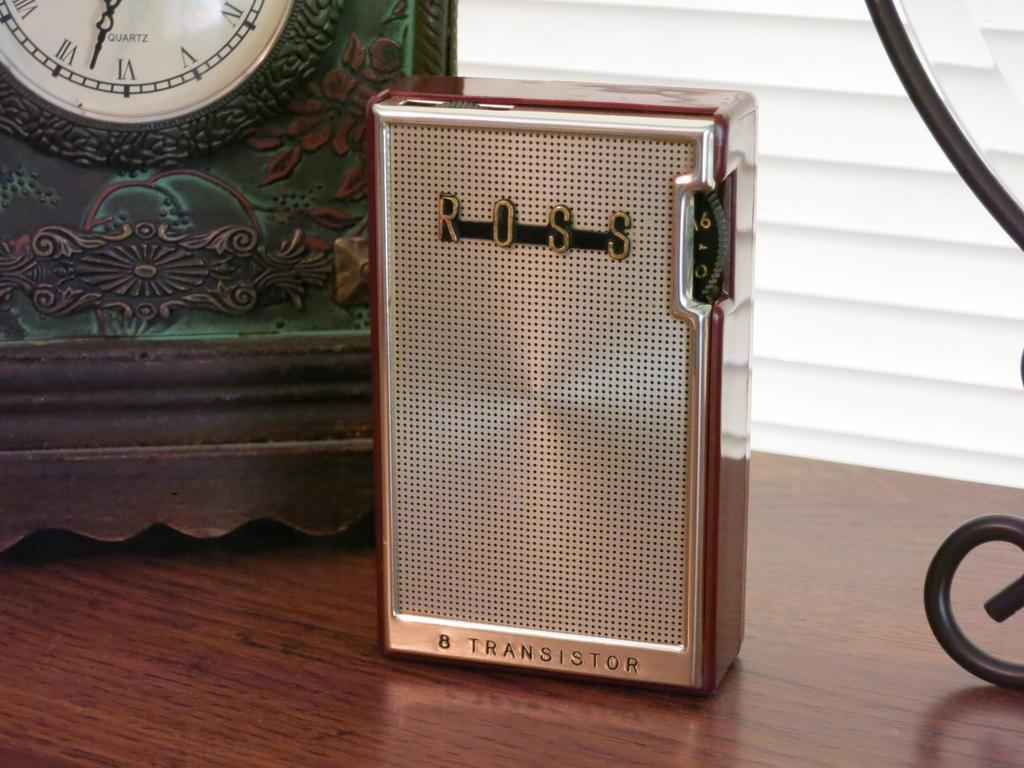Provide a one-sentence caption for the provided image. The transistor sitting infront of the clock was made by ROSS. 